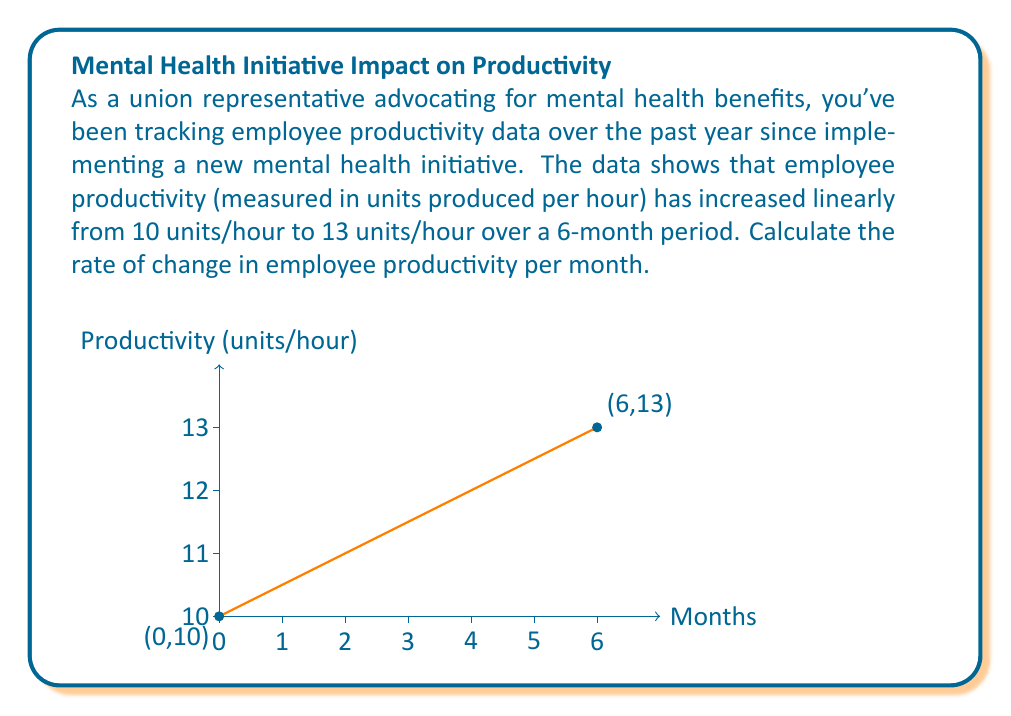Can you answer this question? To calculate the rate of change in employee productivity per month, we need to determine the slope of the line representing the productivity increase over time.

Given:
- Initial productivity: 10 units/hour
- Final productivity: 13 units/hour
- Time period: 6 months

Step 1: Calculate the change in productivity.
$$\Delta y = y_2 - y_1 = 13 - 10 = 3 \text{ units/hour}$$

Step 2: Calculate the change in time.
$$\Delta x = x_2 - x_1 = 6 - 0 = 6 \text{ months}$$

Step 3: Calculate the rate of change (slope) using the formula:
$$\text{Rate of change} = \frac{\Delta y}{\Delta x} = \frac{3 \text{ units/hour}}{6 \text{ months}}$$

Step 4: Simplify the fraction:
$$\text{Rate of change} = \frac{1 \text{ unit/hour}}{2 \text{ months}} = 0.5 \text{ units/hour per month}$$

Therefore, the rate of change in employee productivity is 0.5 units/hour per month.
Answer: 0.5 units/hour per month 